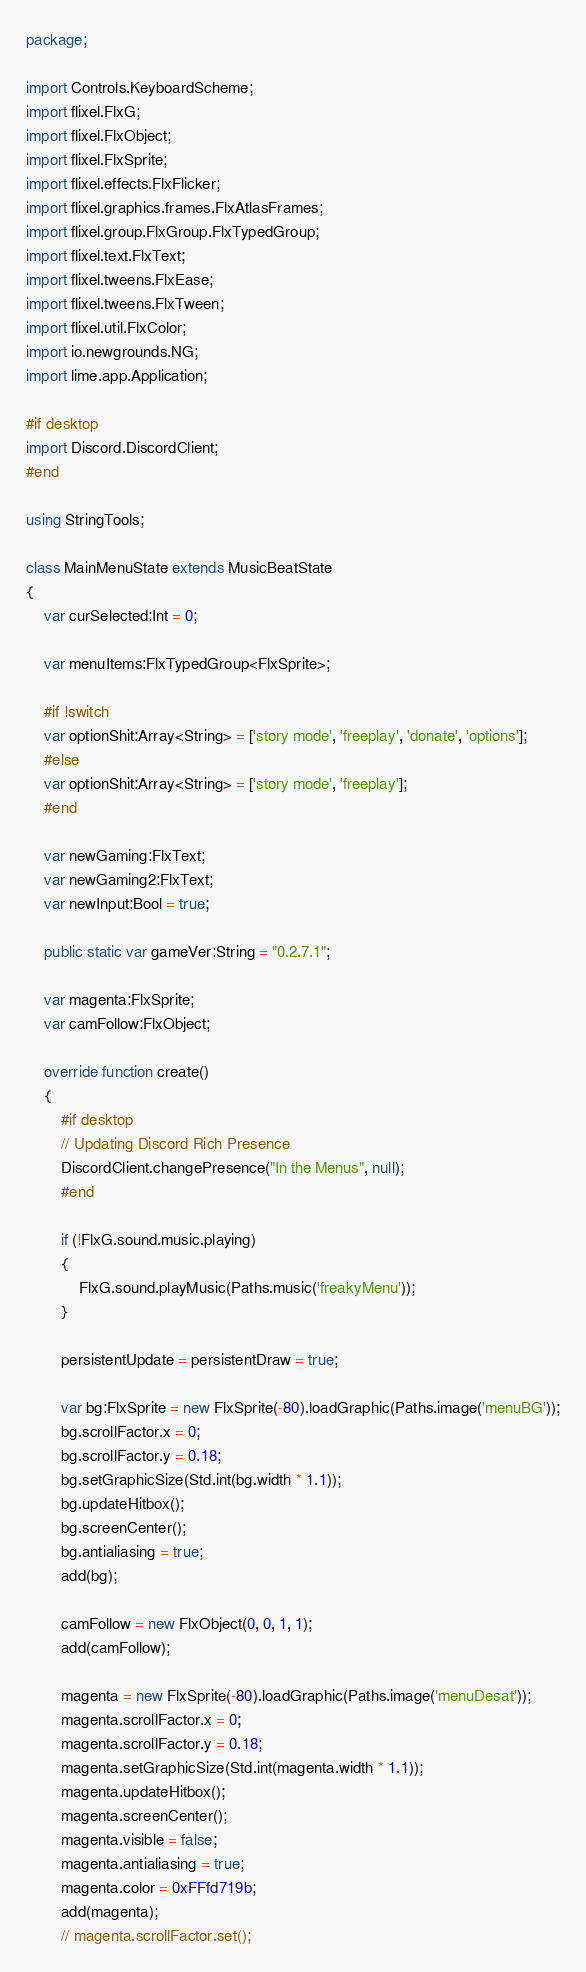Convert code to text. <code><loc_0><loc_0><loc_500><loc_500><_Haxe_>package;

import Controls.KeyboardScheme;
import flixel.FlxG;
import flixel.FlxObject;
import flixel.FlxSprite;
import flixel.effects.FlxFlicker;
import flixel.graphics.frames.FlxAtlasFrames;
import flixel.group.FlxGroup.FlxTypedGroup;
import flixel.text.FlxText;
import flixel.tweens.FlxEase;
import flixel.tweens.FlxTween;
import flixel.util.FlxColor;
import io.newgrounds.NG;
import lime.app.Application;

#if desktop
import Discord.DiscordClient;
#end

using StringTools;

class MainMenuState extends MusicBeatState
{
	var curSelected:Int = 0;

	var menuItems:FlxTypedGroup<FlxSprite>;

	#if !switch
	var optionShit:Array<String> = ['story mode', 'freeplay', 'donate', 'options'];
	#else
	var optionShit:Array<String> = ['story mode', 'freeplay'];
	#end

	var newGaming:FlxText;
	var newGaming2:FlxText;
	var newInput:Bool = true;

	public static var gameVer:String = "0.2.7.1";

	var magenta:FlxSprite;
	var camFollow:FlxObject;

	override function create()
	{
		#if desktop
		// Updating Discord Rich Presence
		DiscordClient.changePresence("In the Menus", null);
		#end

		if (!FlxG.sound.music.playing)
		{
			FlxG.sound.playMusic(Paths.music('freakyMenu'));
		}

		persistentUpdate = persistentDraw = true;

		var bg:FlxSprite = new FlxSprite(-80).loadGraphic(Paths.image('menuBG'));
		bg.scrollFactor.x = 0;
		bg.scrollFactor.y = 0.18;
		bg.setGraphicSize(Std.int(bg.width * 1.1));
		bg.updateHitbox();
		bg.screenCenter();
		bg.antialiasing = true;
		add(bg);

		camFollow = new FlxObject(0, 0, 1, 1);
		add(camFollow);

		magenta = new FlxSprite(-80).loadGraphic(Paths.image('menuDesat'));
		magenta.scrollFactor.x = 0;
		magenta.scrollFactor.y = 0.18;
		magenta.setGraphicSize(Std.int(magenta.width * 1.1));
		magenta.updateHitbox();
		magenta.screenCenter();
		magenta.visible = false;
		magenta.antialiasing = true;
		magenta.color = 0xFFfd719b;
		add(magenta);
		// magenta.scrollFactor.set();
</code> 